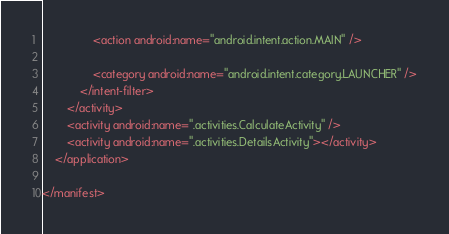<code> <loc_0><loc_0><loc_500><loc_500><_XML_>                <action android:name="android.intent.action.MAIN" />

                <category android:name="android.intent.category.LAUNCHER" />
            </intent-filter>
        </activity>
        <activity android:name=".activities.CalculateActivity" />
        <activity android:name=".activities.DetailsActivity"></activity>
    </application>

</manifest></code> 